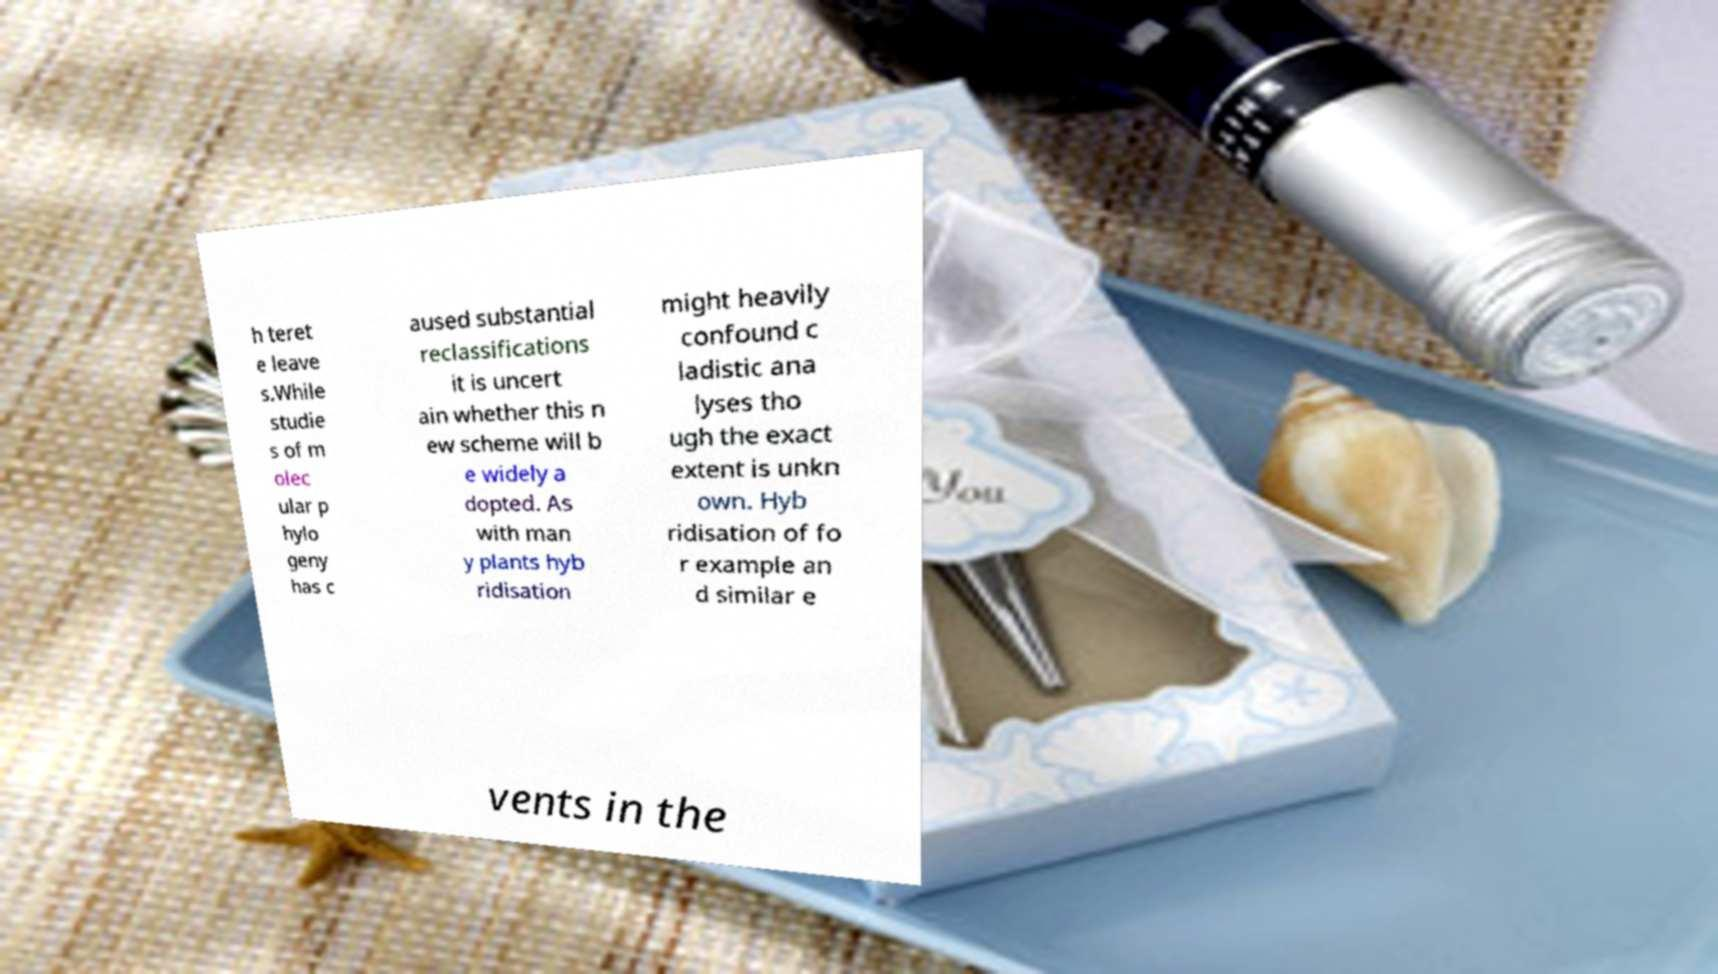Could you extract and type out the text from this image? h teret e leave s.While studie s of m olec ular p hylo geny has c aused substantial reclassifications it is uncert ain whether this n ew scheme will b e widely a dopted. As with man y plants hyb ridisation might heavily confound c ladistic ana lyses tho ugh the exact extent is unkn own. Hyb ridisation of fo r example an d similar e vents in the 